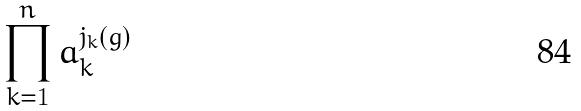<formula> <loc_0><loc_0><loc_500><loc_500>\prod _ { k = 1 } ^ { n } a _ { k } ^ { j _ { k } ( g ) }</formula> 